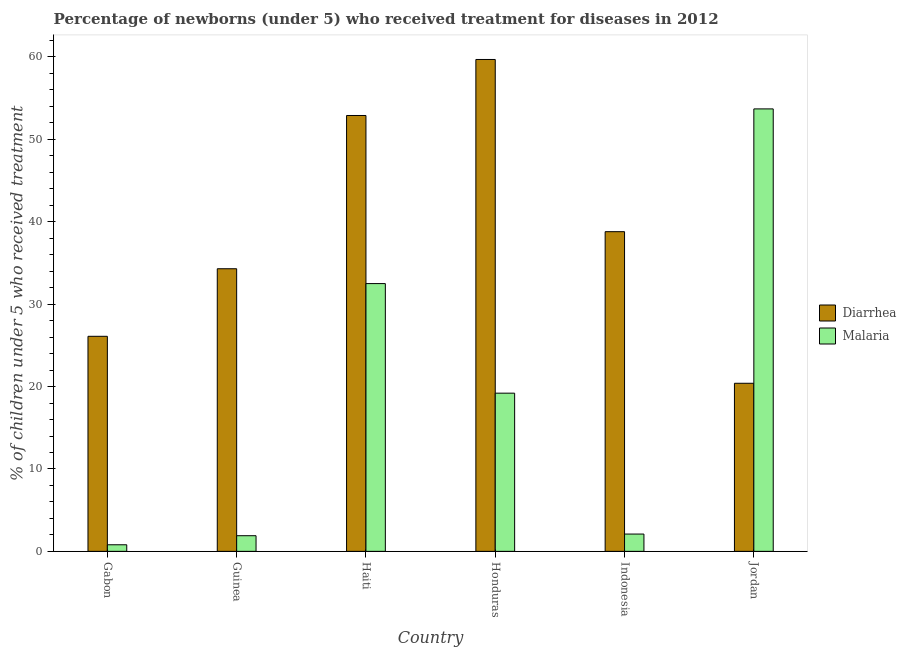How many different coloured bars are there?
Provide a succinct answer. 2. How many groups of bars are there?
Ensure brevity in your answer.  6. Are the number of bars on each tick of the X-axis equal?
Your answer should be very brief. Yes. What is the label of the 1st group of bars from the left?
Ensure brevity in your answer.  Gabon. In how many cases, is the number of bars for a given country not equal to the number of legend labels?
Provide a succinct answer. 0. What is the percentage of children who received treatment for malaria in Jordan?
Give a very brief answer. 53.7. Across all countries, what is the maximum percentage of children who received treatment for malaria?
Offer a terse response. 53.7. Across all countries, what is the minimum percentage of children who received treatment for diarrhoea?
Your response must be concise. 20.4. In which country was the percentage of children who received treatment for diarrhoea maximum?
Provide a succinct answer. Honduras. In which country was the percentage of children who received treatment for malaria minimum?
Give a very brief answer. Gabon. What is the total percentage of children who received treatment for diarrhoea in the graph?
Your answer should be compact. 232.2. What is the difference between the percentage of children who received treatment for malaria in Gabon and that in Haiti?
Offer a very short reply. -31.7. What is the difference between the percentage of children who received treatment for malaria in Haiti and the percentage of children who received treatment for diarrhoea in Honduras?
Your answer should be very brief. -27.2. What is the average percentage of children who received treatment for malaria per country?
Your answer should be very brief. 18.37. What is the difference between the percentage of children who received treatment for diarrhoea and percentage of children who received treatment for malaria in Indonesia?
Give a very brief answer. 36.7. What is the ratio of the percentage of children who received treatment for diarrhoea in Honduras to that in Jordan?
Your response must be concise. 2.93. Is the percentage of children who received treatment for malaria in Honduras less than that in Jordan?
Make the answer very short. Yes. What is the difference between the highest and the second highest percentage of children who received treatment for malaria?
Keep it short and to the point. 21.2. What is the difference between the highest and the lowest percentage of children who received treatment for diarrhoea?
Make the answer very short. 39.3. What does the 2nd bar from the left in Jordan represents?
Your response must be concise. Malaria. What does the 1st bar from the right in Guinea represents?
Your response must be concise. Malaria. How many bars are there?
Your answer should be very brief. 12. Are all the bars in the graph horizontal?
Ensure brevity in your answer.  No. What is the difference between two consecutive major ticks on the Y-axis?
Provide a short and direct response. 10. Are the values on the major ticks of Y-axis written in scientific E-notation?
Make the answer very short. No. Does the graph contain any zero values?
Give a very brief answer. No. What is the title of the graph?
Provide a succinct answer. Percentage of newborns (under 5) who received treatment for diseases in 2012. Does "Education" appear as one of the legend labels in the graph?
Provide a short and direct response. No. What is the label or title of the Y-axis?
Your answer should be compact. % of children under 5 who received treatment. What is the % of children under 5 who received treatment of Diarrhea in Gabon?
Your answer should be very brief. 26.1. What is the % of children under 5 who received treatment in Malaria in Gabon?
Offer a terse response. 0.8. What is the % of children under 5 who received treatment in Diarrhea in Guinea?
Offer a terse response. 34.3. What is the % of children under 5 who received treatment of Diarrhea in Haiti?
Offer a very short reply. 52.9. What is the % of children under 5 who received treatment of Malaria in Haiti?
Ensure brevity in your answer.  32.5. What is the % of children under 5 who received treatment of Diarrhea in Honduras?
Give a very brief answer. 59.7. What is the % of children under 5 who received treatment of Diarrhea in Indonesia?
Your response must be concise. 38.8. What is the % of children under 5 who received treatment of Diarrhea in Jordan?
Offer a terse response. 20.4. What is the % of children under 5 who received treatment of Malaria in Jordan?
Offer a terse response. 53.7. Across all countries, what is the maximum % of children under 5 who received treatment of Diarrhea?
Offer a terse response. 59.7. Across all countries, what is the maximum % of children under 5 who received treatment of Malaria?
Provide a succinct answer. 53.7. Across all countries, what is the minimum % of children under 5 who received treatment in Diarrhea?
Provide a short and direct response. 20.4. Across all countries, what is the minimum % of children under 5 who received treatment in Malaria?
Your response must be concise. 0.8. What is the total % of children under 5 who received treatment of Diarrhea in the graph?
Provide a succinct answer. 232.2. What is the total % of children under 5 who received treatment in Malaria in the graph?
Your answer should be compact. 110.2. What is the difference between the % of children under 5 who received treatment of Malaria in Gabon and that in Guinea?
Provide a succinct answer. -1.1. What is the difference between the % of children under 5 who received treatment in Diarrhea in Gabon and that in Haiti?
Keep it short and to the point. -26.8. What is the difference between the % of children under 5 who received treatment of Malaria in Gabon and that in Haiti?
Keep it short and to the point. -31.7. What is the difference between the % of children under 5 who received treatment in Diarrhea in Gabon and that in Honduras?
Offer a very short reply. -33.6. What is the difference between the % of children under 5 who received treatment of Malaria in Gabon and that in Honduras?
Provide a succinct answer. -18.4. What is the difference between the % of children under 5 who received treatment of Diarrhea in Gabon and that in Indonesia?
Offer a terse response. -12.7. What is the difference between the % of children under 5 who received treatment in Malaria in Gabon and that in Indonesia?
Your answer should be compact. -1.3. What is the difference between the % of children under 5 who received treatment in Diarrhea in Gabon and that in Jordan?
Your response must be concise. 5.7. What is the difference between the % of children under 5 who received treatment in Malaria in Gabon and that in Jordan?
Your answer should be compact. -52.9. What is the difference between the % of children under 5 who received treatment in Diarrhea in Guinea and that in Haiti?
Your response must be concise. -18.6. What is the difference between the % of children under 5 who received treatment of Malaria in Guinea and that in Haiti?
Give a very brief answer. -30.6. What is the difference between the % of children under 5 who received treatment of Diarrhea in Guinea and that in Honduras?
Offer a terse response. -25.4. What is the difference between the % of children under 5 who received treatment of Malaria in Guinea and that in Honduras?
Give a very brief answer. -17.3. What is the difference between the % of children under 5 who received treatment of Diarrhea in Guinea and that in Jordan?
Make the answer very short. 13.9. What is the difference between the % of children under 5 who received treatment in Malaria in Guinea and that in Jordan?
Give a very brief answer. -51.8. What is the difference between the % of children under 5 who received treatment of Diarrhea in Haiti and that in Honduras?
Keep it short and to the point. -6.8. What is the difference between the % of children under 5 who received treatment of Diarrhea in Haiti and that in Indonesia?
Provide a short and direct response. 14.1. What is the difference between the % of children under 5 who received treatment in Malaria in Haiti and that in Indonesia?
Provide a succinct answer. 30.4. What is the difference between the % of children under 5 who received treatment of Diarrhea in Haiti and that in Jordan?
Make the answer very short. 32.5. What is the difference between the % of children under 5 who received treatment of Malaria in Haiti and that in Jordan?
Make the answer very short. -21.2. What is the difference between the % of children under 5 who received treatment of Diarrhea in Honduras and that in Indonesia?
Your answer should be compact. 20.9. What is the difference between the % of children under 5 who received treatment of Diarrhea in Honduras and that in Jordan?
Provide a succinct answer. 39.3. What is the difference between the % of children under 5 who received treatment in Malaria in Honduras and that in Jordan?
Offer a terse response. -34.5. What is the difference between the % of children under 5 who received treatment in Malaria in Indonesia and that in Jordan?
Ensure brevity in your answer.  -51.6. What is the difference between the % of children under 5 who received treatment in Diarrhea in Gabon and the % of children under 5 who received treatment in Malaria in Guinea?
Your answer should be compact. 24.2. What is the difference between the % of children under 5 who received treatment of Diarrhea in Gabon and the % of children under 5 who received treatment of Malaria in Honduras?
Ensure brevity in your answer.  6.9. What is the difference between the % of children under 5 who received treatment of Diarrhea in Gabon and the % of children under 5 who received treatment of Malaria in Indonesia?
Your answer should be compact. 24. What is the difference between the % of children under 5 who received treatment of Diarrhea in Gabon and the % of children under 5 who received treatment of Malaria in Jordan?
Provide a succinct answer. -27.6. What is the difference between the % of children under 5 who received treatment of Diarrhea in Guinea and the % of children under 5 who received treatment of Malaria in Indonesia?
Provide a succinct answer. 32.2. What is the difference between the % of children under 5 who received treatment of Diarrhea in Guinea and the % of children under 5 who received treatment of Malaria in Jordan?
Your response must be concise. -19.4. What is the difference between the % of children under 5 who received treatment in Diarrhea in Haiti and the % of children under 5 who received treatment in Malaria in Honduras?
Keep it short and to the point. 33.7. What is the difference between the % of children under 5 who received treatment of Diarrhea in Haiti and the % of children under 5 who received treatment of Malaria in Indonesia?
Your response must be concise. 50.8. What is the difference between the % of children under 5 who received treatment of Diarrhea in Honduras and the % of children under 5 who received treatment of Malaria in Indonesia?
Your answer should be very brief. 57.6. What is the difference between the % of children under 5 who received treatment of Diarrhea in Honduras and the % of children under 5 who received treatment of Malaria in Jordan?
Give a very brief answer. 6. What is the difference between the % of children under 5 who received treatment in Diarrhea in Indonesia and the % of children under 5 who received treatment in Malaria in Jordan?
Keep it short and to the point. -14.9. What is the average % of children under 5 who received treatment in Diarrhea per country?
Ensure brevity in your answer.  38.7. What is the average % of children under 5 who received treatment of Malaria per country?
Make the answer very short. 18.37. What is the difference between the % of children under 5 who received treatment of Diarrhea and % of children under 5 who received treatment of Malaria in Gabon?
Your response must be concise. 25.3. What is the difference between the % of children under 5 who received treatment in Diarrhea and % of children under 5 who received treatment in Malaria in Guinea?
Keep it short and to the point. 32.4. What is the difference between the % of children under 5 who received treatment of Diarrhea and % of children under 5 who received treatment of Malaria in Haiti?
Your response must be concise. 20.4. What is the difference between the % of children under 5 who received treatment in Diarrhea and % of children under 5 who received treatment in Malaria in Honduras?
Your response must be concise. 40.5. What is the difference between the % of children under 5 who received treatment of Diarrhea and % of children under 5 who received treatment of Malaria in Indonesia?
Provide a succinct answer. 36.7. What is the difference between the % of children under 5 who received treatment in Diarrhea and % of children under 5 who received treatment in Malaria in Jordan?
Make the answer very short. -33.3. What is the ratio of the % of children under 5 who received treatment of Diarrhea in Gabon to that in Guinea?
Offer a terse response. 0.76. What is the ratio of the % of children under 5 who received treatment of Malaria in Gabon to that in Guinea?
Your answer should be very brief. 0.42. What is the ratio of the % of children under 5 who received treatment of Diarrhea in Gabon to that in Haiti?
Ensure brevity in your answer.  0.49. What is the ratio of the % of children under 5 who received treatment in Malaria in Gabon to that in Haiti?
Provide a succinct answer. 0.02. What is the ratio of the % of children under 5 who received treatment of Diarrhea in Gabon to that in Honduras?
Ensure brevity in your answer.  0.44. What is the ratio of the % of children under 5 who received treatment of Malaria in Gabon to that in Honduras?
Provide a succinct answer. 0.04. What is the ratio of the % of children under 5 who received treatment of Diarrhea in Gabon to that in Indonesia?
Your answer should be compact. 0.67. What is the ratio of the % of children under 5 who received treatment of Malaria in Gabon to that in Indonesia?
Provide a short and direct response. 0.38. What is the ratio of the % of children under 5 who received treatment of Diarrhea in Gabon to that in Jordan?
Provide a succinct answer. 1.28. What is the ratio of the % of children under 5 who received treatment in Malaria in Gabon to that in Jordan?
Your response must be concise. 0.01. What is the ratio of the % of children under 5 who received treatment in Diarrhea in Guinea to that in Haiti?
Offer a terse response. 0.65. What is the ratio of the % of children under 5 who received treatment of Malaria in Guinea to that in Haiti?
Your answer should be very brief. 0.06. What is the ratio of the % of children under 5 who received treatment of Diarrhea in Guinea to that in Honduras?
Your answer should be compact. 0.57. What is the ratio of the % of children under 5 who received treatment in Malaria in Guinea to that in Honduras?
Your answer should be very brief. 0.1. What is the ratio of the % of children under 5 who received treatment of Diarrhea in Guinea to that in Indonesia?
Provide a short and direct response. 0.88. What is the ratio of the % of children under 5 who received treatment in Malaria in Guinea to that in Indonesia?
Make the answer very short. 0.9. What is the ratio of the % of children under 5 who received treatment in Diarrhea in Guinea to that in Jordan?
Make the answer very short. 1.68. What is the ratio of the % of children under 5 who received treatment of Malaria in Guinea to that in Jordan?
Give a very brief answer. 0.04. What is the ratio of the % of children under 5 who received treatment in Diarrhea in Haiti to that in Honduras?
Give a very brief answer. 0.89. What is the ratio of the % of children under 5 who received treatment in Malaria in Haiti to that in Honduras?
Make the answer very short. 1.69. What is the ratio of the % of children under 5 who received treatment of Diarrhea in Haiti to that in Indonesia?
Offer a terse response. 1.36. What is the ratio of the % of children under 5 who received treatment of Malaria in Haiti to that in Indonesia?
Your answer should be very brief. 15.48. What is the ratio of the % of children under 5 who received treatment of Diarrhea in Haiti to that in Jordan?
Ensure brevity in your answer.  2.59. What is the ratio of the % of children under 5 who received treatment in Malaria in Haiti to that in Jordan?
Give a very brief answer. 0.61. What is the ratio of the % of children under 5 who received treatment of Diarrhea in Honduras to that in Indonesia?
Make the answer very short. 1.54. What is the ratio of the % of children under 5 who received treatment in Malaria in Honduras to that in Indonesia?
Give a very brief answer. 9.14. What is the ratio of the % of children under 5 who received treatment in Diarrhea in Honduras to that in Jordan?
Offer a very short reply. 2.93. What is the ratio of the % of children under 5 who received treatment of Malaria in Honduras to that in Jordan?
Make the answer very short. 0.36. What is the ratio of the % of children under 5 who received treatment in Diarrhea in Indonesia to that in Jordan?
Give a very brief answer. 1.9. What is the ratio of the % of children under 5 who received treatment of Malaria in Indonesia to that in Jordan?
Your answer should be very brief. 0.04. What is the difference between the highest and the second highest % of children under 5 who received treatment of Diarrhea?
Offer a terse response. 6.8. What is the difference between the highest and the second highest % of children under 5 who received treatment of Malaria?
Offer a terse response. 21.2. What is the difference between the highest and the lowest % of children under 5 who received treatment of Diarrhea?
Provide a short and direct response. 39.3. What is the difference between the highest and the lowest % of children under 5 who received treatment in Malaria?
Make the answer very short. 52.9. 